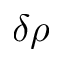Convert formula to latex. <formula><loc_0><loc_0><loc_500><loc_500>\delta \rho</formula> 